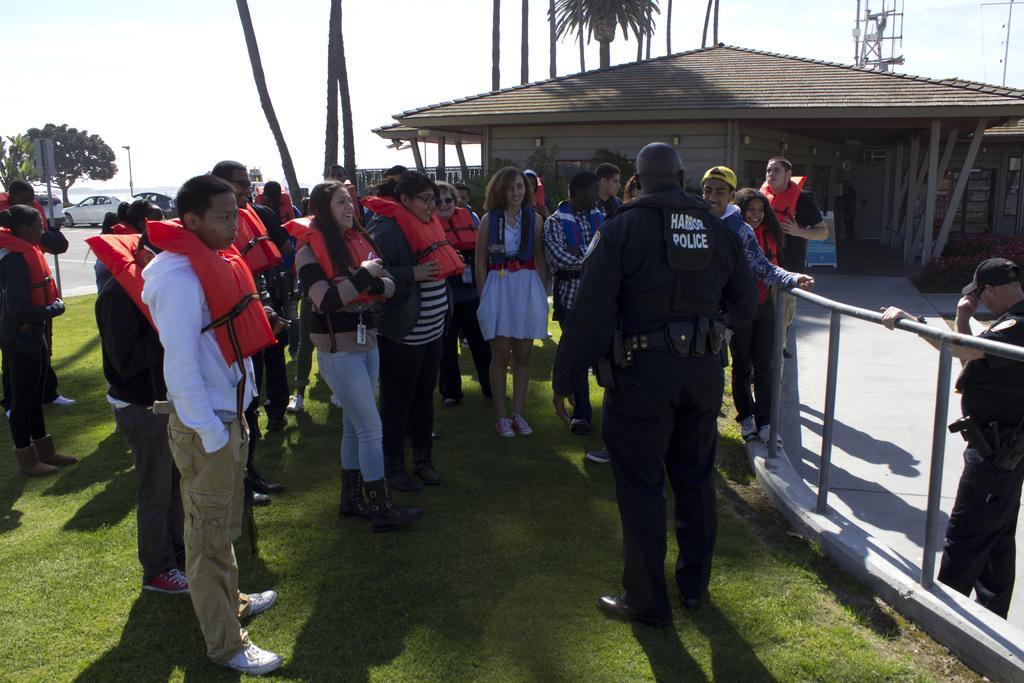Could you give a brief overview of what you see in this image? In this image we can see few persons standing on the ground, some of them are wearing life jackets, there is a house, also an object under it, we can see some trees, vehicles, poles, fence, and the sky. 